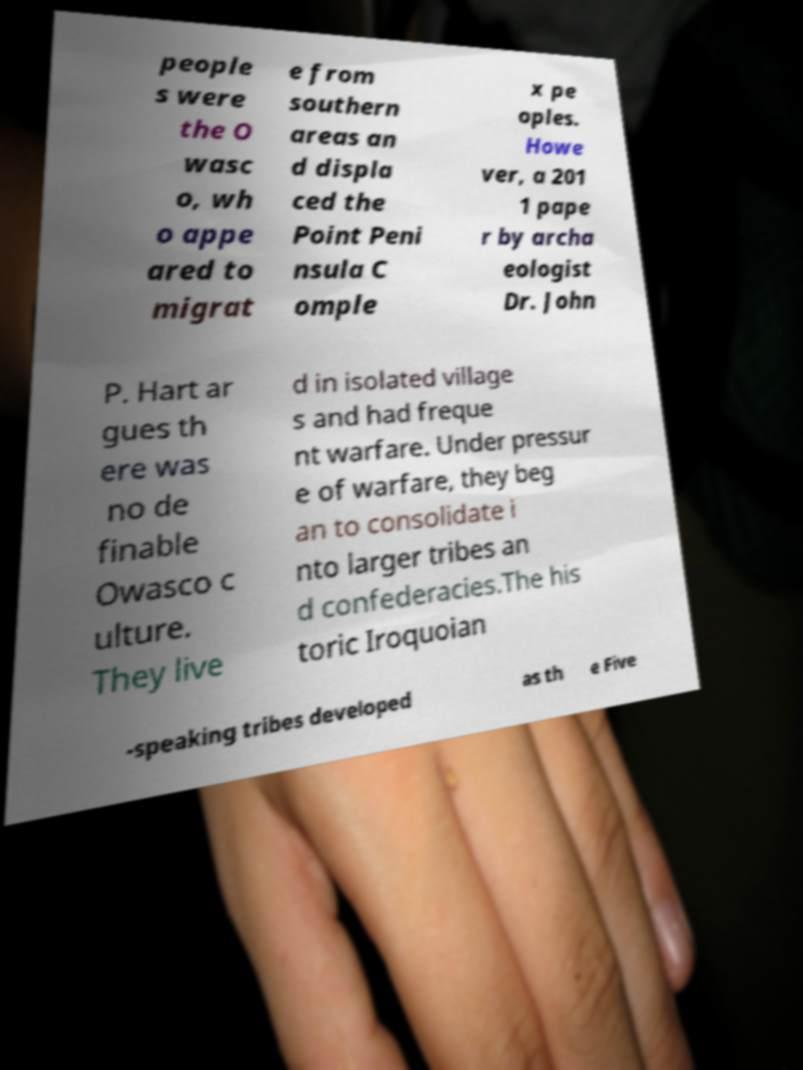Please identify and transcribe the text found in this image. people s were the O wasc o, wh o appe ared to migrat e from southern areas an d displa ced the Point Peni nsula C omple x pe oples. Howe ver, a 201 1 pape r by archa eologist Dr. John P. Hart ar gues th ere was no de finable Owasco c ulture. They live d in isolated village s and had freque nt warfare. Under pressur e of warfare, they beg an to consolidate i nto larger tribes an d confederacies.The his toric Iroquoian -speaking tribes developed as th e Five 